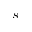<formula> <loc_0><loc_0><loc_500><loc_500>s</formula> 